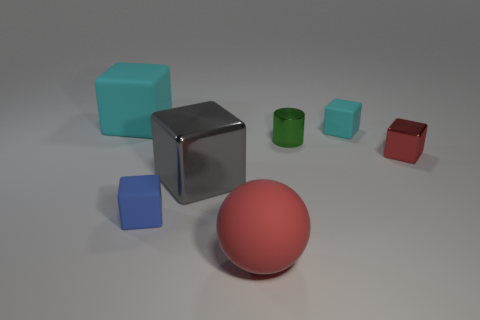Are there any large cyan things that have the same material as the small blue cube?
Make the answer very short. Yes. There is a big cube that is right of the blue rubber cube; what is its material?
Keep it short and to the point. Metal. What is the red ball made of?
Keep it short and to the point. Rubber. Do the large thing in front of the blue object and the large cyan cube have the same material?
Provide a succinct answer. Yes. Is the number of large cyan rubber objects that are in front of the green shiny cylinder less than the number of big red rubber objects?
Your response must be concise. Yes. The ball that is the same size as the gray thing is what color?
Keep it short and to the point. Red. How many blue things have the same shape as the tiny cyan object?
Provide a succinct answer. 1. The block that is to the left of the small blue rubber thing is what color?
Offer a very short reply. Cyan. What number of matte things are big purple cylinders or red cubes?
Provide a succinct answer. 0. There is a tiny object that is the same color as the big sphere; what shape is it?
Your response must be concise. Cube. 